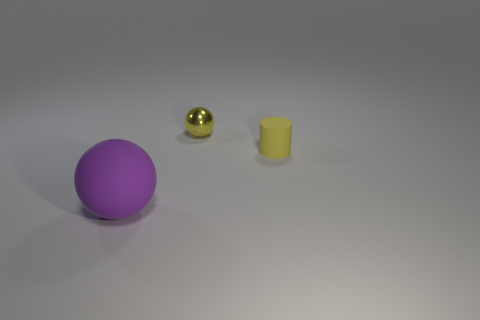Add 1 large matte blocks. How many objects exist? 4 Subtract all cylinders. How many objects are left? 2 Add 2 green rubber blocks. How many green rubber blocks exist? 2 Subtract 0 purple cylinders. How many objects are left? 3 Subtract all tiny spheres. Subtract all big purple objects. How many objects are left? 1 Add 1 tiny yellow metal objects. How many tiny yellow metal objects are left? 2 